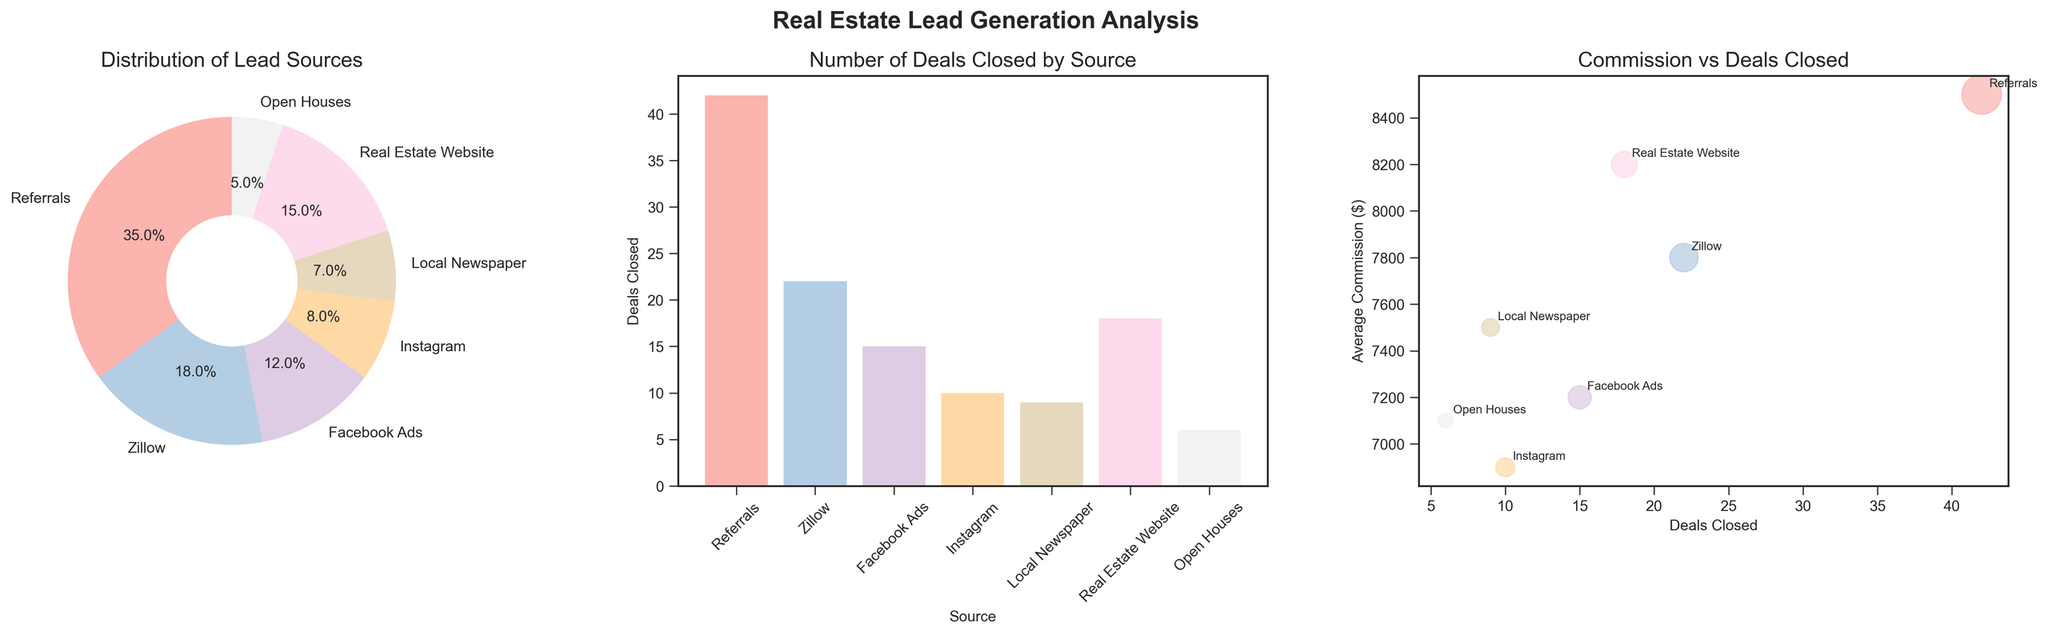What's the largest percentage of lead generation source? The pie chart shows that the referral source has the largest percentage slice compared to the other sources.
Answer: 35% How many deals were closed by Facebook Ads? The bar chart indicates the number of deals closed by each source. For Facebook Ads, there is a bar at the "15" mark.
Answer: 15 Which lead generation source has the highest average commission? By looking at the scatter plot, the point with the highest y-axis value shows the average commission for each source. Referrals have the highest average commission at $8,500.
Answer: Referrals How does the number of deals closed by Instagram compare to the number closed by Zillow? The bar chart shows that Instagram closed 10 deals, while Zillow closed 22. Therefore, Zillow closed more deals than Instagram.
Answer: Zillow closed more deals What's the combined percentage of leads from online marketing sources like Zillow, Facebook Ads, and Instagram? Add the percentages from Zillow (18%), Facebook Ads (12%), and Instagram (8%). 18 + 12 + 8 = 38%.
Answer: 38% Which lead generation source resulted in the lowest number of deals closed? The bar chart shows that the shortest bar corresponds to Open Houses, indicating it resulted in only 6 deals closed.
Answer: Open Houses What correlation can be interpreted between the number of deals closed and the average commission? The scatter plot suggests that sources with higher numbers of deals tend to cluster around average commission values, with no clear positive or negative correlation. Referrals, for instance, have a high average commission but not the highest number of deals closed.
Answer: No clear correlation How does the average commission for deals from Local Newspaper compare to that from Real Estate Website? By checking the scatter plot, Local Newspaper has around $7,500, and Real Estate Website has around $8,200 as average commission. Hence, the Real Estate Website has a higher average commission.
Answer: Real Estate Website has a higher average commission What's the difference in deals closed between the top and bottom lead generation sources? The bar chart shows that the top source (Referrals) closed 42 deals, and the bottom source (Open Houses) closed 6 deals. The difference is 42 - 6 = 36.
Answer: 36 Which source appears at the rightmost position in the scatter plot? The scatter plot shows Real Estate Website furthest to the right with 18 deals closed.
Answer: Real Estate Website 